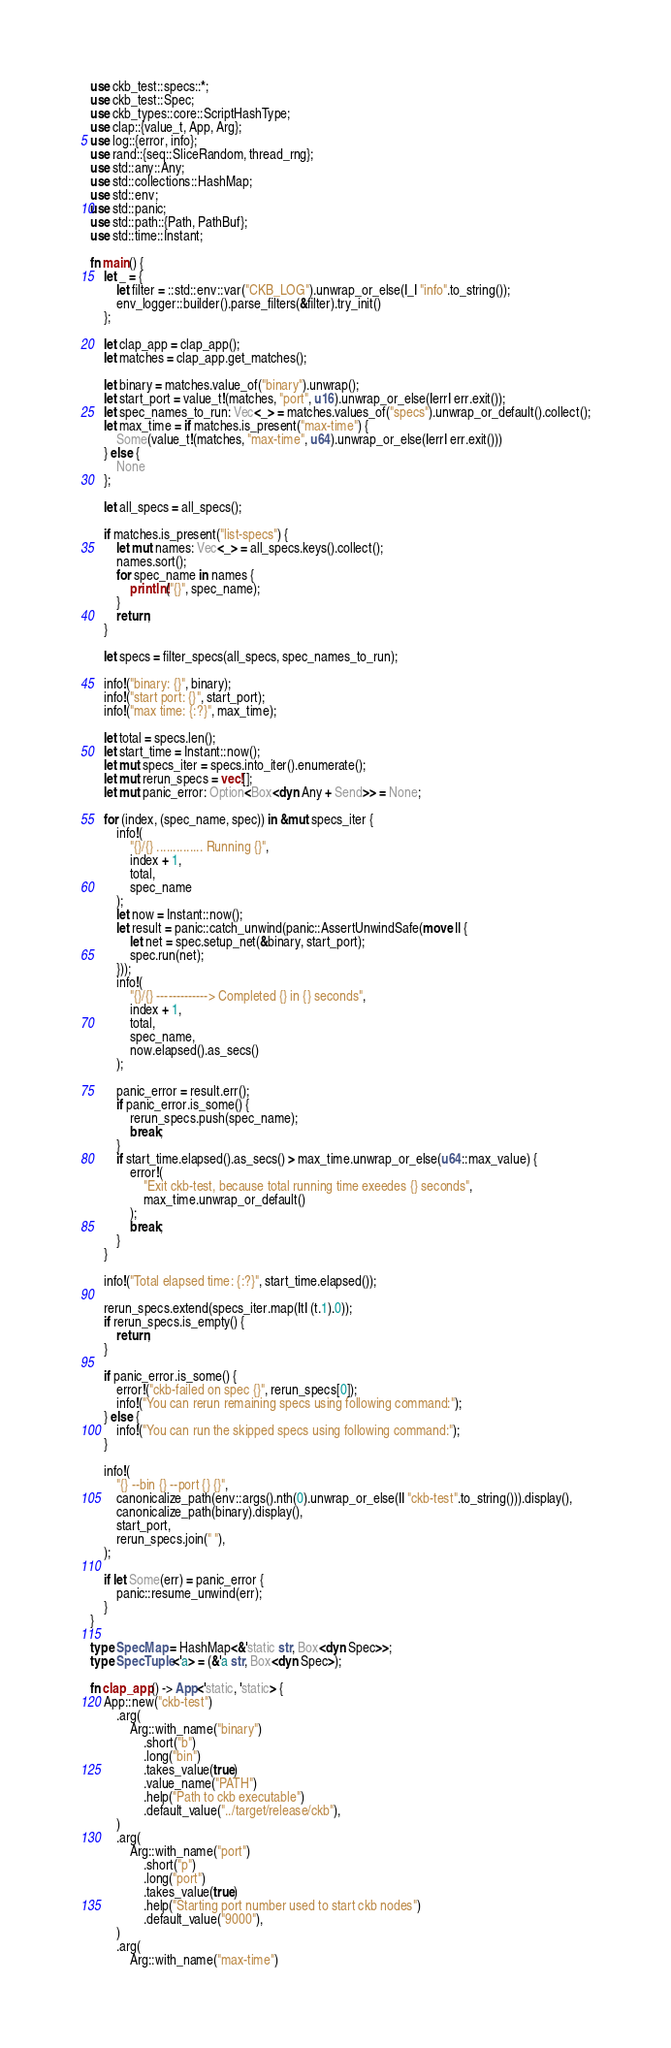<code> <loc_0><loc_0><loc_500><loc_500><_Rust_>use ckb_test::specs::*;
use ckb_test::Spec;
use ckb_types::core::ScriptHashType;
use clap::{value_t, App, Arg};
use log::{error, info};
use rand::{seq::SliceRandom, thread_rng};
use std::any::Any;
use std::collections::HashMap;
use std::env;
use std::panic;
use std::path::{Path, PathBuf};
use std::time::Instant;

fn main() {
    let _ = {
        let filter = ::std::env::var("CKB_LOG").unwrap_or_else(|_| "info".to_string());
        env_logger::builder().parse_filters(&filter).try_init()
    };

    let clap_app = clap_app();
    let matches = clap_app.get_matches();

    let binary = matches.value_of("binary").unwrap();
    let start_port = value_t!(matches, "port", u16).unwrap_or_else(|err| err.exit());
    let spec_names_to_run: Vec<_> = matches.values_of("specs").unwrap_or_default().collect();
    let max_time = if matches.is_present("max-time") {
        Some(value_t!(matches, "max-time", u64).unwrap_or_else(|err| err.exit()))
    } else {
        None
    };

    let all_specs = all_specs();

    if matches.is_present("list-specs") {
        let mut names: Vec<_> = all_specs.keys().collect();
        names.sort();
        for spec_name in names {
            println!("{}", spec_name);
        }
        return;
    }

    let specs = filter_specs(all_specs, spec_names_to_run);

    info!("binary: {}", binary);
    info!("start port: {}", start_port);
    info!("max time: {:?}", max_time);

    let total = specs.len();
    let start_time = Instant::now();
    let mut specs_iter = specs.into_iter().enumerate();
    let mut rerun_specs = vec![];
    let mut panic_error: Option<Box<dyn Any + Send>> = None;

    for (index, (spec_name, spec)) in &mut specs_iter {
        info!(
            "{}/{} .............. Running {}",
            index + 1,
            total,
            spec_name
        );
        let now = Instant::now();
        let result = panic::catch_unwind(panic::AssertUnwindSafe(move || {
            let net = spec.setup_net(&binary, start_port);
            spec.run(net);
        }));
        info!(
            "{}/{} -------------> Completed {} in {} seconds",
            index + 1,
            total,
            spec_name,
            now.elapsed().as_secs()
        );

        panic_error = result.err();
        if panic_error.is_some() {
            rerun_specs.push(spec_name);
            break;
        }
        if start_time.elapsed().as_secs() > max_time.unwrap_or_else(u64::max_value) {
            error!(
                "Exit ckb-test, because total running time exeedes {} seconds",
                max_time.unwrap_or_default()
            );
            break;
        }
    }

    info!("Total elapsed time: {:?}", start_time.elapsed());

    rerun_specs.extend(specs_iter.map(|t| (t.1).0));
    if rerun_specs.is_empty() {
        return;
    }

    if panic_error.is_some() {
        error!("ckb-failed on spec {}", rerun_specs[0]);
        info!("You can rerun remaining specs using following command:");
    } else {
        info!("You can run the skipped specs using following command:");
    }

    info!(
        "{} --bin {} --port {} {}",
        canonicalize_path(env::args().nth(0).unwrap_or_else(|| "ckb-test".to_string())).display(),
        canonicalize_path(binary).display(),
        start_port,
        rerun_specs.join(" "),
    );

    if let Some(err) = panic_error {
        panic::resume_unwind(err);
    }
}

type SpecMap = HashMap<&'static str, Box<dyn Spec>>;
type SpecTuple<'a> = (&'a str, Box<dyn Spec>);

fn clap_app() -> App<'static, 'static> {
    App::new("ckb-test")
        .arg(
            Arg::with_name("binary")
                .short("b")
                .long("bin")
                .takes_value(true)
                .value_name("PATH")
                .help("Path to ckb executable")
                .default_value("../target/release/ckb"),
        )
        .arg(
            Arg::with_name("port")
                .short("p")
                .long("port")
                .takes_value(true)
                .help("Starting port number used to start ckb nodes")
                .default_value("9000"),
        )
        .arg(
            Arg::with_name("max-time")</code> 